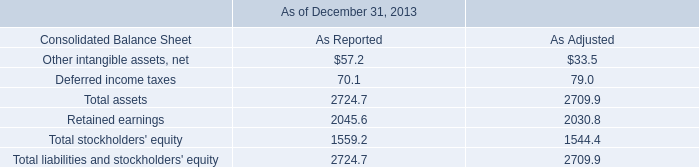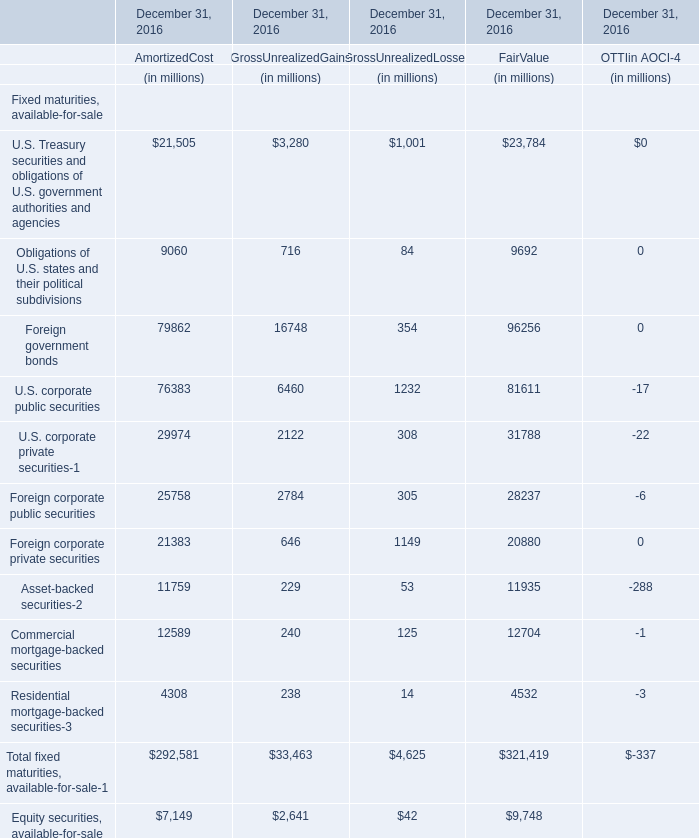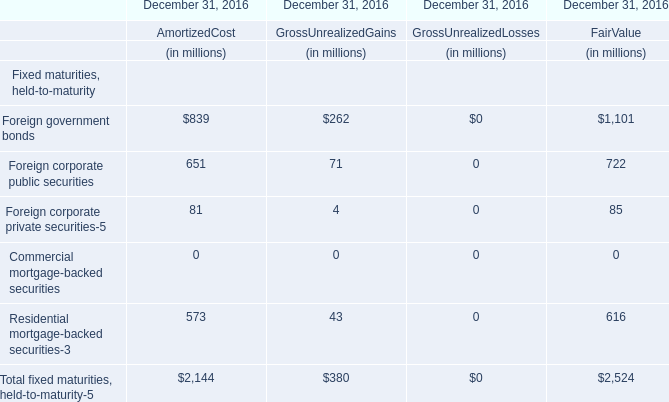What was the total amount of Foreign government bonds greater than 1 for AmortizedCost GrossUnrealizedGains 
Computations: (839 + 262)
Answer: 1101.0. 